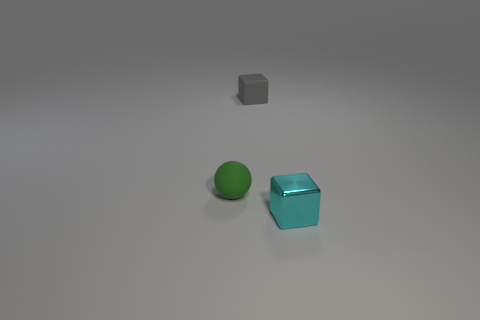There is a small gray cube; how many green balls are behind it?
Your response must be concise. 0. Is the small thing that is to the right of the gray thing made of the same material as the thing on the left side of the tiny gray object?
Offer a terse response. No. What color is the ball that is the same size as the metal object?
Offer a terse response. Green. What size is the object to the left of the cube that is behind the tiny thing in front of the green thing?
Provide a short and direct response. Small. The object that is both in front of the gray rubber thing and on the right side of the rubber sphere is what color?
Give a very brief answer. Cyan. What size is the cube that is in front of the ball?
Provide a short and direct response. Small. How many gray objects are made of the same material as the green sphere?
Provide a succinct answer. 1. Is the shape of the object in front of the green object the same as  the gray object?
Provide a short and direct response. Yes. What color is the small sphere that is made of the same material as the gray object?
Ensure brevity in your answer.  Green. Is there a small metallic object behind the block right of the tiny block left of the metallic object?
Your answer should be compact. No. 